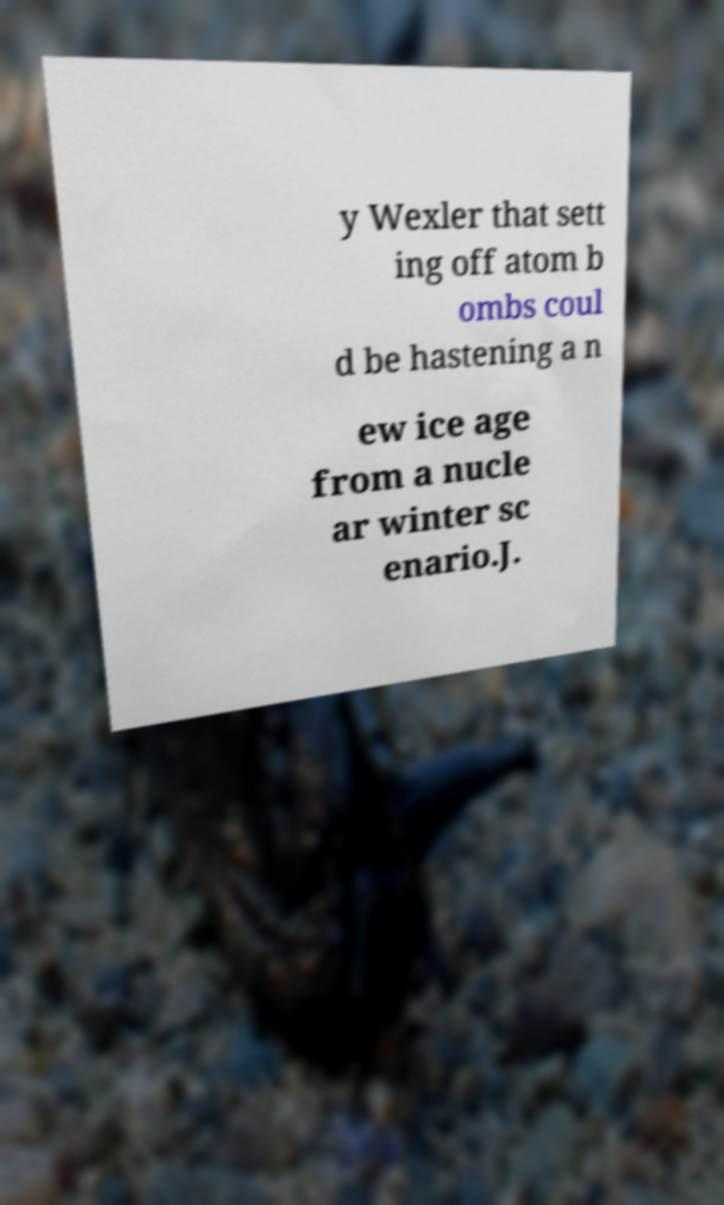Can you read and provide the text displayed in the image?This photo seems to have some interesting text. Can you extract and type it out for me? y Wexler that sett ing off atom b ombs coul d be hastening a n ew ice age from a nucle ar winter sc enario.J. 